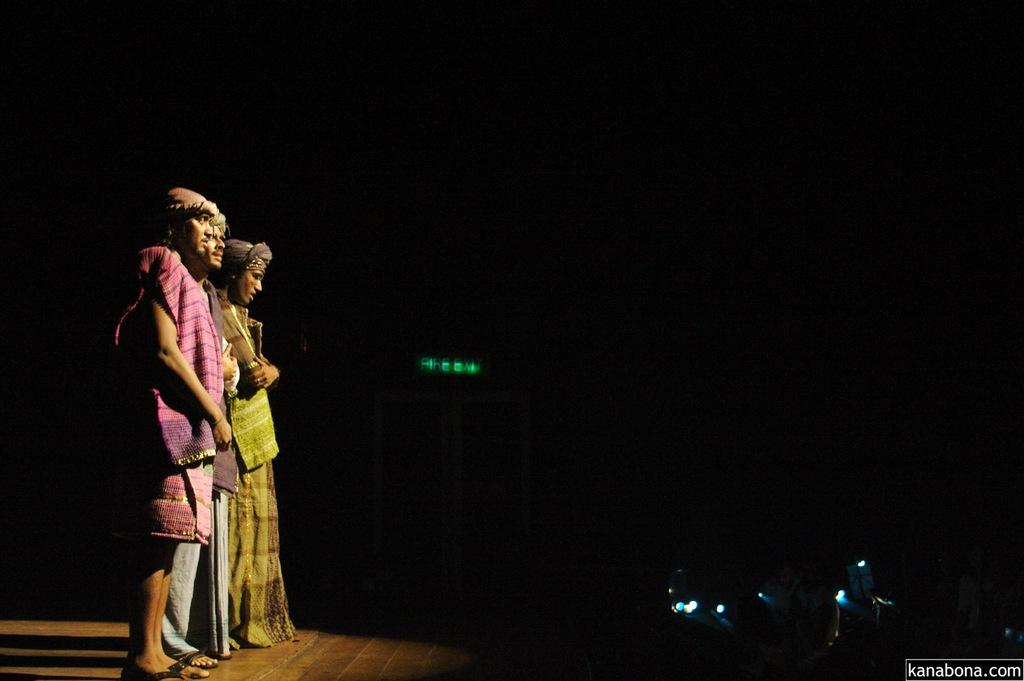What are the people in the image doing? The people are standing on the stage in the image. What can be seen in the background of the image? There is a door visible in the background of the image. How would you describe the lighting in the image? The background of the image is dark. What type of spy equipment can be seen on the stage in the image? There is no spy equipment visible on the stage in the image. How does the industry contribute to the increase in the number of people on the stage in the image? The image does not depict any industry or mention an increase in the number of people on the stage. 